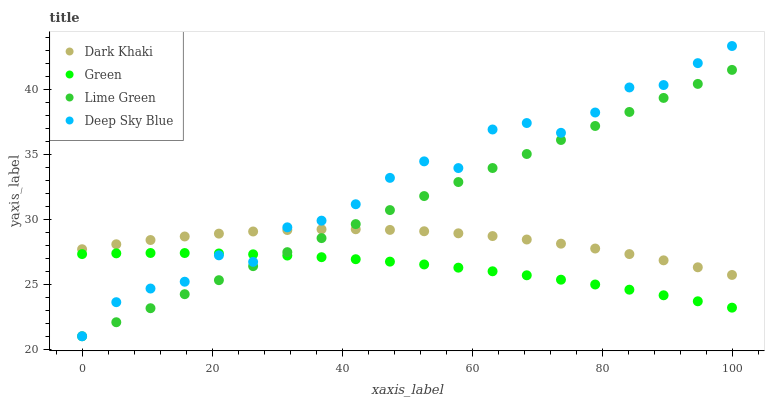Does Green have the minimum area under the curve?
Answer yes or no. Yes. Does Deep Sky Blue have the maximum area under the curve?
Answer yes or no. Yes. Does Lime Green have the minimum area under the curve?
Answer yes or no. No. Does Lime Green have the maximum area under the curve?
Answer yes or no. No. Is Lime Green the smoothest?
Answer yes or no. Yes. Is Deep Sky Blue the roughest?
Answer yes or no. Yes. Is Green the smoothest?
Answer yes or no. No. Is Green the roughest?
Answer yes or no. No. Does Lime Green have the lowest value?
Answer yes or no. Yes. Does Green have the lowest value?
Answer yes or no. No. Does Deep Sky Blue have the highest value?
Answer yes or no. Yes. Does Lime Green have the highest value?
Answer yes or no. No. Is Green less than Dark Khaki?
Answer yes or no. Yes. Is Dark Khaki greater than Green?
Answer yes or no. Yes. Does Deep Sky Blue intersect Lime Green?
Answer yes or no. Yes. Is Deep Sky Blue less than Lime Green?
Answer yes or no. No. Is Deep Sky Blue greater than Lime Green?
Answer yes or no. No. Does Green intersect Dark Khaki?
Answer yes or no. No. 